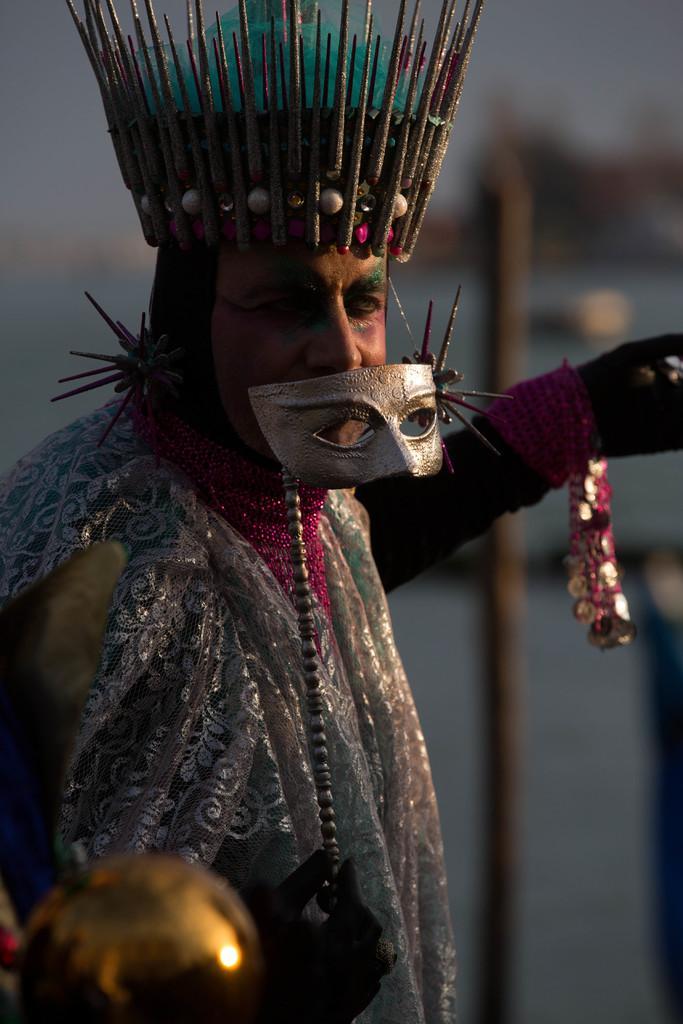In one or two sentences, can you explain what this image depicts? In this image we can see a person wearing some costume holding mask in his hand and wearing a head band. In the background we can see a pole. 